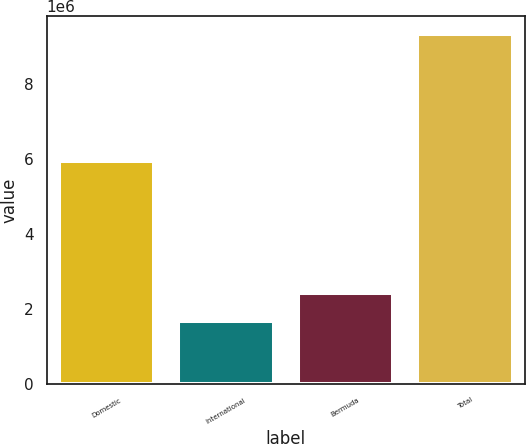Convert chart to OTSL. <chart><loc_0><loc_0><loc_500><loc_500><bar_chart><fcel>Domestic<fcel>International<fcel>Bermuda<fcel>Total<nl><fcel>5.94471e+06<fcel>1.66593e+06<fcel>2.43336e+06<fcel>9.34018e+06<nl></chart> 